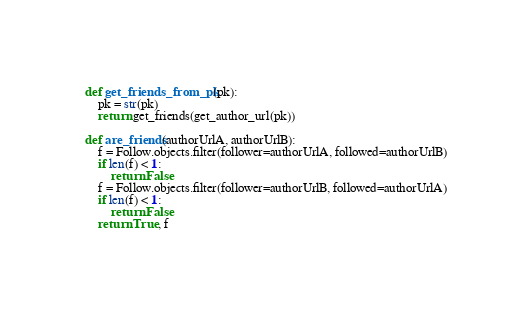<code> <loc_0><loc_0><loc_500><loc_500><_Python_>def get_friends_from_pk(pk):
    pk = str(pk)
    return get_friends(get_author_url(pk))

def are_friends(authorUrlA, authorUrlB):
    f = Follow.objects.filter(follower=authorUrlA, followed=authorUrlB)
    if len(f) < 1:
        return False
    f = Follow.objects.filter(follower=authorUrlB, followed=authorUrlA)
    if len(f) < 1:
        return False
    return True, f</code> 